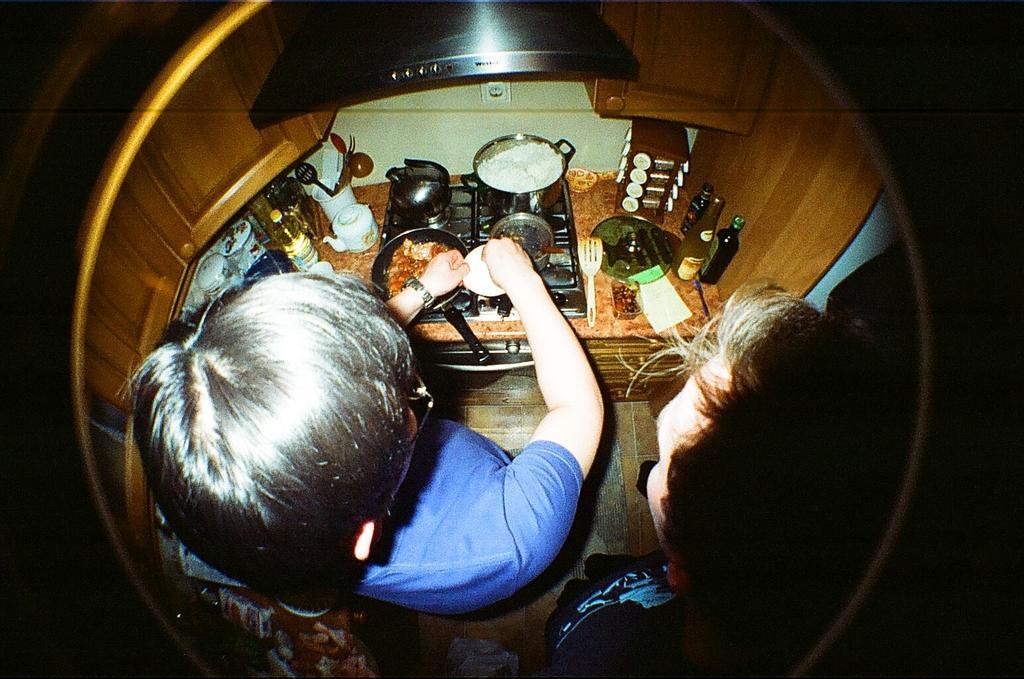In one or two sentences, can you explain what this image depicts? This image is clicked from a top view. There are two people standing. In front of them there is a kitchen platform. On the platform there is a four burner stove. There are utensils on the stove. Beside the stove there are bottles, cutlery, jars and bowls. At the top there is a chimney. 